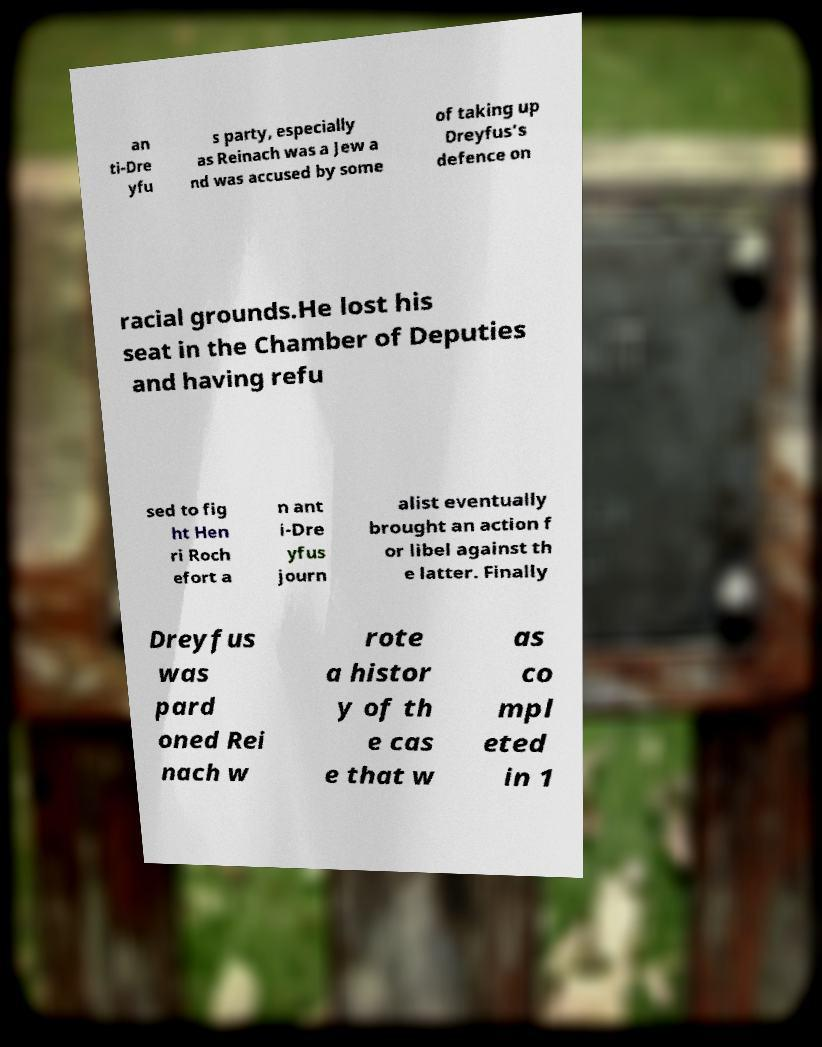Could you assist in decoding the text presented in this image and type it out clearly? an ti-Dre yfu s party, especially as Reinach was a Jew a nd was accused by some of taking up Dreyfus's defence on racial grounds.He lost his seat in the Chamber of Deputies and having refu sed to fig ht Hen ri Roch efort a n ant i-Dre yfus journ alist eventually brought an action f or libel against th e latter. Finally Dreyfus was pard oned Rei nach w rote a histor y of th e cas e that w as co mpl eted in 1 